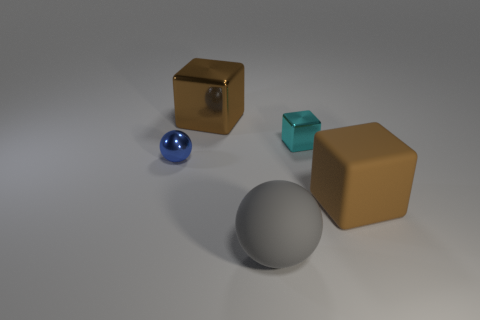Subtract all tiny cyan shiny blocks. How many blocks are left? 2 Add 1 blue metal spheres. How many objects exist? 6 Subtract all balls. How many objects are left? 3 Subtract all blue spheres. How many spheres are left? 1 Add 2 cubes. How many cubes are left? 5 Add 3 small cyan metallic objects. How many small cyan metallic objects exist? 4 Subtract 0 purple spheres. How many objects are left? 5 Subtract 2 cubes. How many cubes are left? 1 Subtract all red cubes. Subtract all blue spheres. How many cubes are left? 3 Subtract all purple spheres. How many cyan cubes are left? 1 